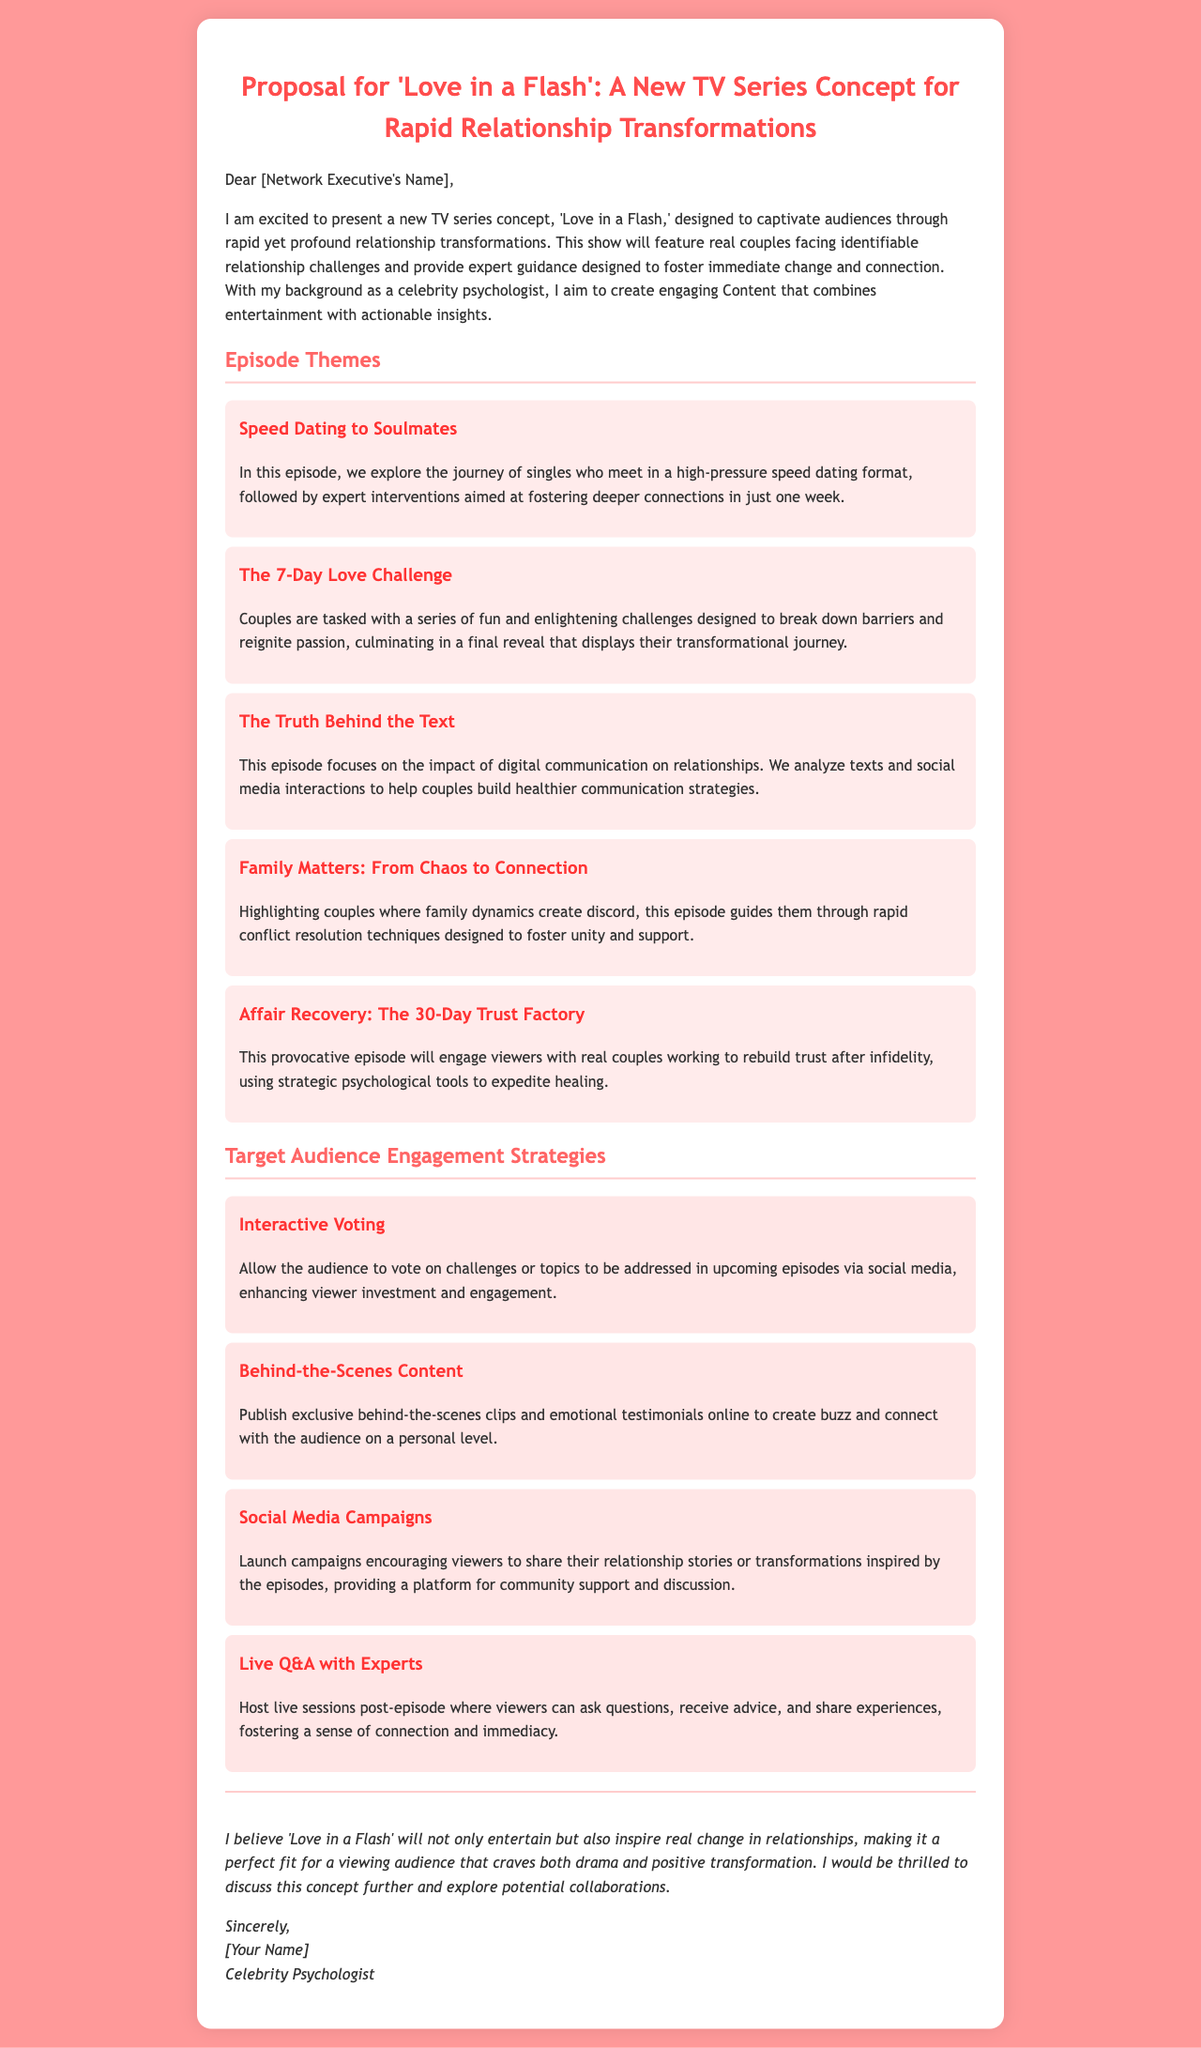What is the title of the proposed TV series? The title of the proposed TV series is mentioned at the beginning of the document.
Answer: Love in a Flash What is the main focus of the series? The main focus of the series is stated in the introduction of the document.
Answer: Rapid relationship transformations How many episode themes are proposed? The number of episode themes can be counted in the document where they are listed.
Answer: Five What is the theme of the first episode? The theme of the first episode is specified in the episode section of the document.
Answer: Speed Dating to Soulmates What is one engagement strategy mentioned in the document? The document lists several strategies aimed at engaging the audience.
Answer: Interactive Voting What is the unique aspect of the episode about affair recovery? The unique aspect can be found in the specific explanation for the corresponding episode.
Answer: The 30-Day Trust Factory What type of content is suggested for social media campaigns? The document describes what kind of content should be shared through social media.
Answer: Relationship stories or transformations What expert role does the author hold? The document introduces the author's professional background.
Answer: Celebrity Psychologist What kind of reveal is mentioned in "The 7-Day Love Challenge"? The document describes what culminates the challenges in this episode.
Answer: Final reveal 